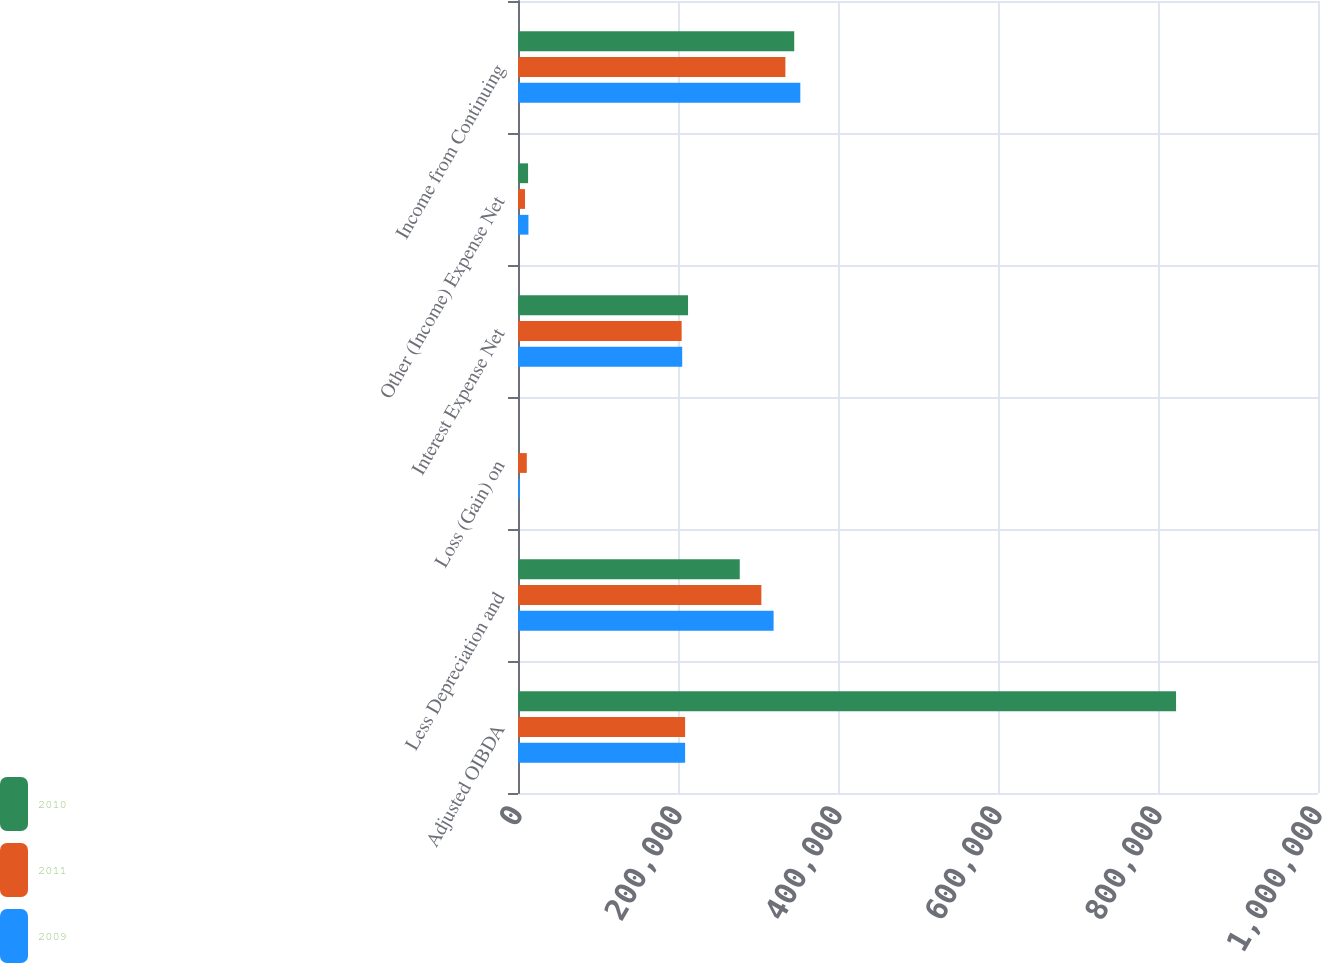Convert chart to OTSL. <chart><loc_0><loc_0><loc_500><loc_500><stacked_bar_chart><ecel><fcel>Adjusted OIBDA<fcel>Less Depreciation and<fcel>Loss (Gain) on<fcel>Interest Expense Net<fcel>Other (Income) Expense Net<fcel>Income from Continuing<nl><fcel>2010<fcel>822579<fcel>277186<fcel>168<fcel>212545<fcel>12599<fcel>345279<nl><fcel>2011<fcel>208900<fcel>304205<fcel>10987<fcel>204559<fcel>8768<fcel>334222<nl><fcel>2009<fcel>208900<fcel>319499<fcel>2286<fcel>205256<fcel>13043<fcel>352900<nl></chart> 